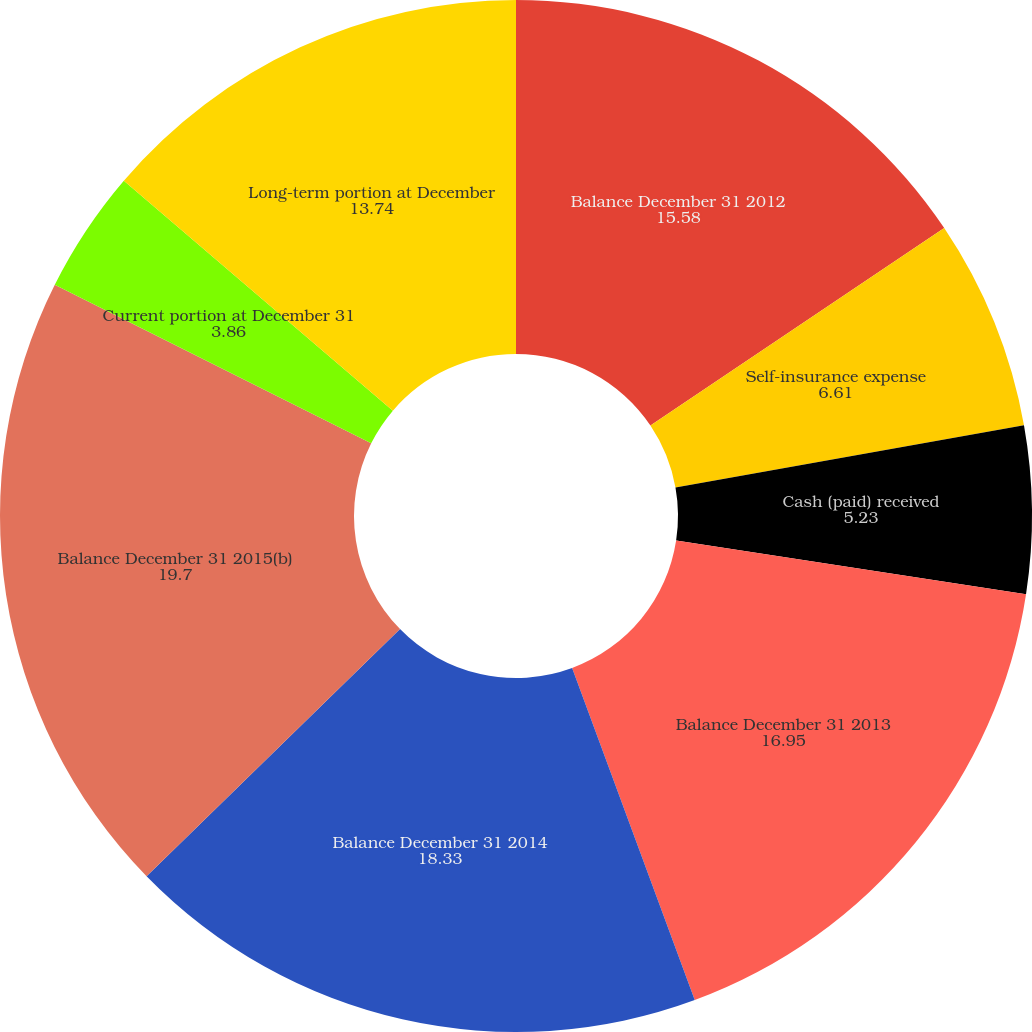Convert chart. <chart><loc_0><loc_0><loc_500><loc_500><pie_chart><fcel>Balance December 31 2012<fcel>Self-insurance expense<fcel>Cash (paid) received<fcel>Balance December 31 2013<fcel>Balance December 31 2014<fcel>Balance December 31 2015(b)<fcel>Current portion at December 31<fcel>Long-term portion at December<nl><fcel>15.58%<fcel>6.61%<fcel>5.23%<fcel>16.95%<fcel>18.33%<fcel>19.7%<fcel>3.86%<fcel>13.74%<nl></chart> 